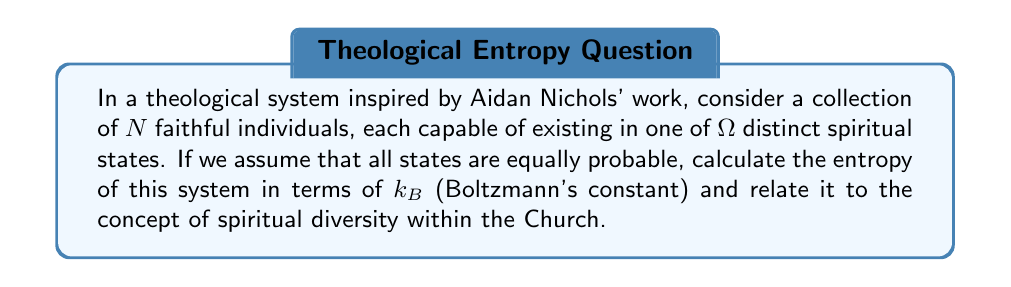Teach me how to tackle this problem. To solve this problem, we'll follow these steps:

1) In statistical mechanics, the entropy $S$ of a system with $\Omega$ equally probable microstates is given by the Boltzmann formula:

   $$S = k_B \ln \Omega$$

2) In our theological analogy, $\Omega$ represents the total number of possible configurations of the spiritual states of all individuals. Since each individual can be in one of $\Omega$ states, and there are $N$ individuals, the total number of possible configurations is:

   $$\Omega_{total} = \Omega^N$$

3) Substituting this into the Boltzmann formula:

   $$S = k_B \ln (\Omega^N) = k_B N \ln \Omega$$

4) This result can be interpreted theologically:
   - $N$ represents the number of faithful individuals in the Church
   - $\Omega$ represents the diversity of spiritual states or charisms
   - The logarithmic nature of the formula suggests that spiritual diversity contributes more to the richness of the Church than sheer numbers
   - The linear dependence on $N$ indicates that each individual contributes equally to the overall spiritual entropy of the Church

5) In Aidan Nichols' theology, this could be seen as a mathematical representation of the unity in diversity within the Catholic Church, where a multiplicity of spiritual gifts and states (high $\Omega$) contributes to the richness of the Church's life.
Answer: $S = k_B N \ln \Omega$ 